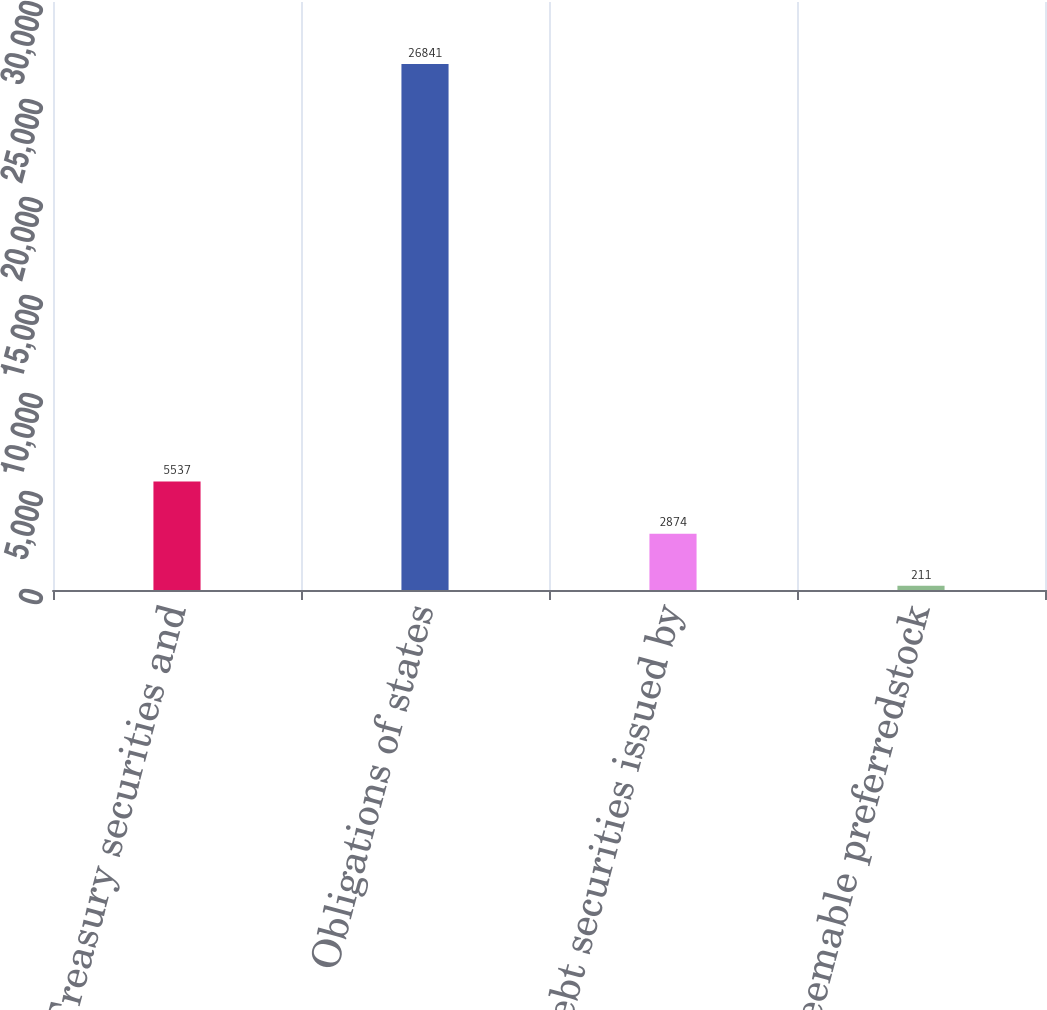Convert chart. <chart><loc_0><loc_0><loc_500><loc_500><bar_chart><fcel>US Treasury securities and<fcel>Obligations of states<fcel>Debt securities issued by<fcel>Redeemable preferredstock<nl><fcel>5537<fcel>26841<fcel>2874<fcel>211<nl></chart> 